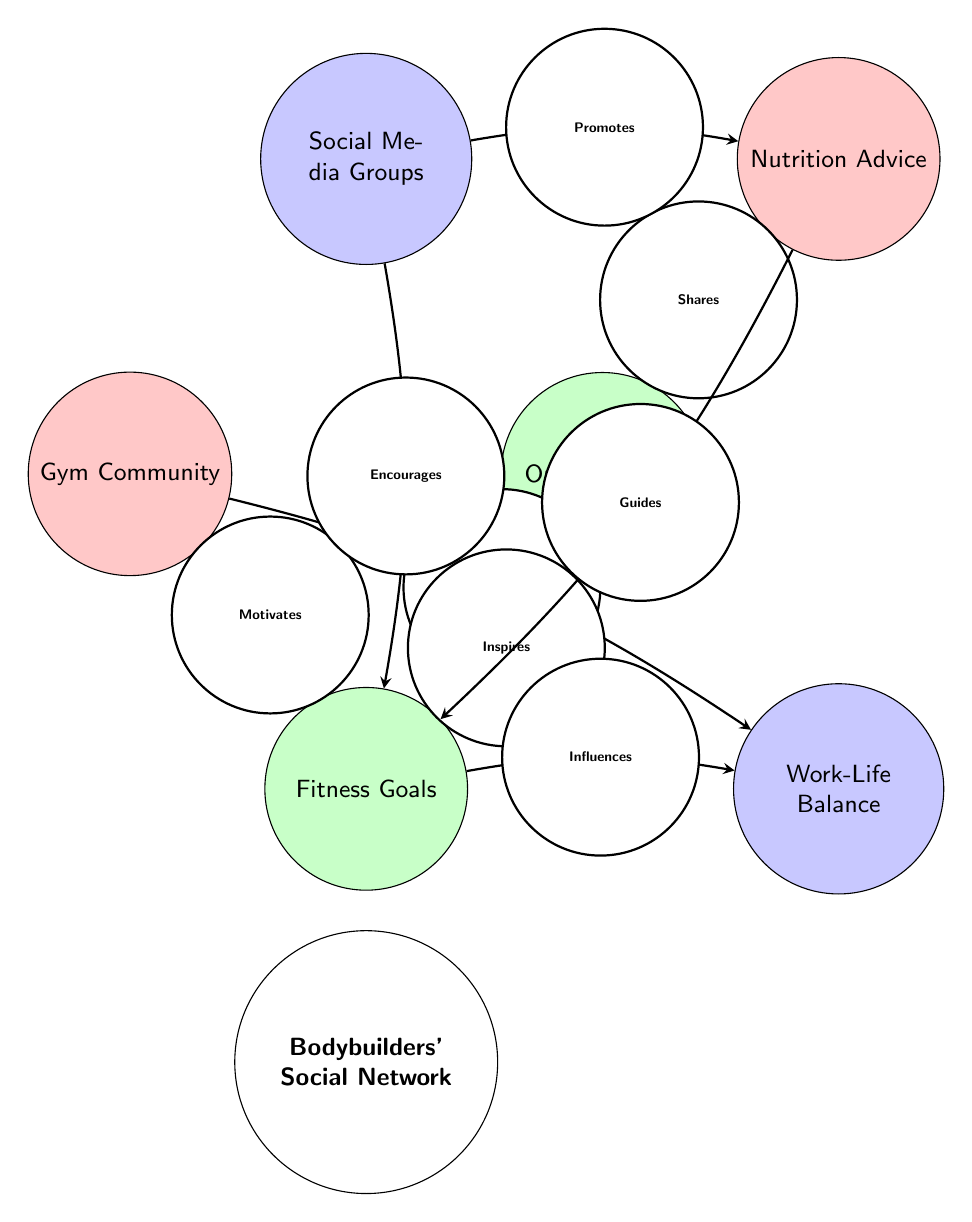What are the nodes connected to the 'Gym Community'? The 'Gym Community' node connects to 'Fitness Goals' with the label 'Motivates' and to 'Work-Life Balance' with the label 'Supports'. This indicates the relationships it has with these two nodes.
Answer: Fitness Goals, Work-Life Balance How many total nodes are present in the diagram? The diagram illustrates a total of 6 nodes: Gym Community, Online Forums, Social Media Groups, Nutrition Advice, Fitness Goals, and Work-Life Balance. There are no missing nodes, providing a complete view of the social network.
Answer: 6 Which node influences 'Work-Life Balance'? The diagram indicates that 'Fitness Goals' influences 'Work-Life Balance', as shown by the directed edge labeled 'Influences' from 'Fitness Goals' to 'Work-Life Balance'.
Answer: Fitness Goals What is the direct relationship between 'Online Forums' and 'Nutrition Advice'? The direct relationship is represented by an edge that indicates 'Online Forums' shares 'Nutrition Advice'. This denotes a supportive connection in the social network that facilitates the distribution of nutritional information among bodybuilders.
Answer: Shares Which node provides guidance for 'Fitness Goals'? The guidance for 'Fitness Goals' comes from 'Nutrition Advice', as shown by the directed edge linking these two nodes with the label 'Guides'. This relationship illustrates the importance of nutritional advice in achieving fitness goals.
Answer: Nutrition Advice What is the relationship type between 'Social Media Groups' and 'Fitness Goals'? The relationship type is 'Encourages', as indicated by the edge connecting 'Social Media Groups' to 'Fitness Goals'. This emphasizes the role of online social interactions in promoting fitness aspirations among bodybuilders.
Answer: Encourages How many edges are directed towards 'Fitness Goals'? There are three edges directed towards 'Fitness Goals': one from 'Gym Community' (Motivates), one from 'Online Forums' (Inspires), and one from 'Social Media Groups' (Encourages). This indicates various sources of motivation and support for achieving fitness goals.
Answer: 3 Which node directly promotes 'Nutrition Advice'? 'Social Media Groups' directly promotes 'Nutrition Advice', shown by the directed edge with the label 'Promotes'. This illustrates how social media serves as a platform for disseminating nutritional advice in the bodybuilding community.
Answer: Social Media Groups 